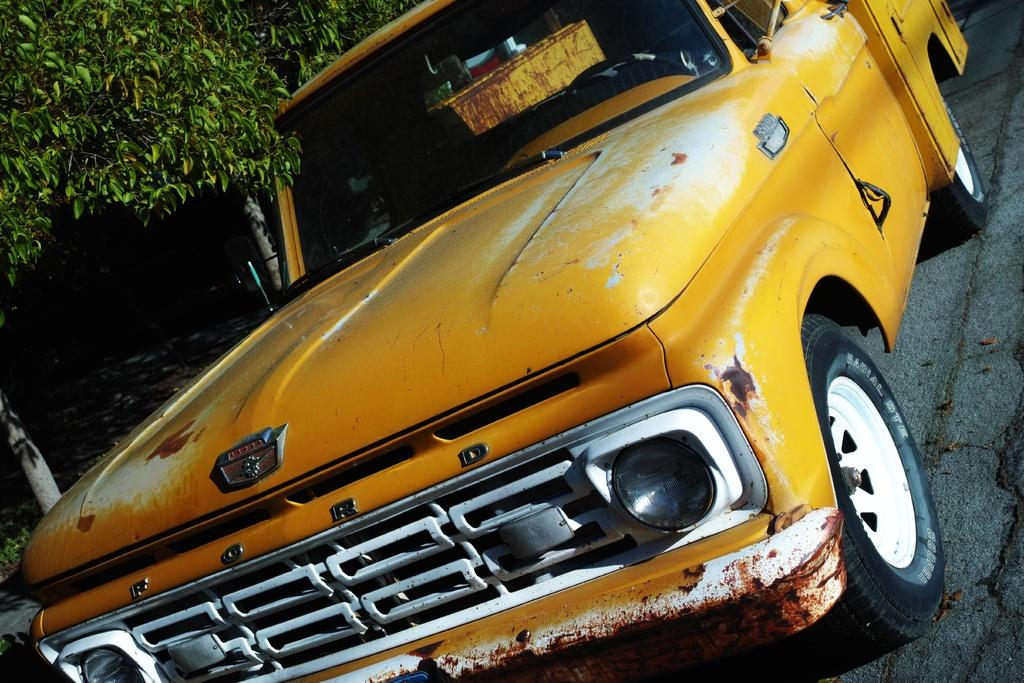What is the main subject in the foreground of the image? There is a vehicle in the foreground of the image. What can be seen in the background of the image? There are trees in the background of the image. What type of drug is being displayed in the image? There is no drug present in the image; it features a vehicle in the foreground and trees in the background. 